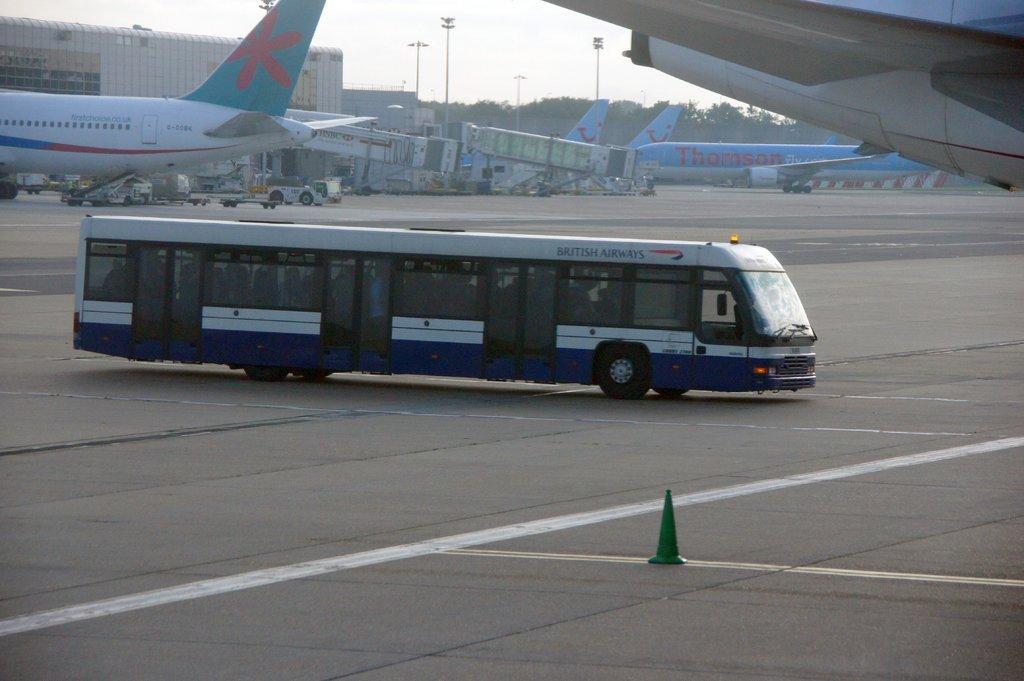In one or two sentences, can you explain what this image depicts? In this picture I can observe bus moving on the runway in the middle of the picture. I can observe airplanes on the runway in this picture. In the background I can observe trees and sky. 